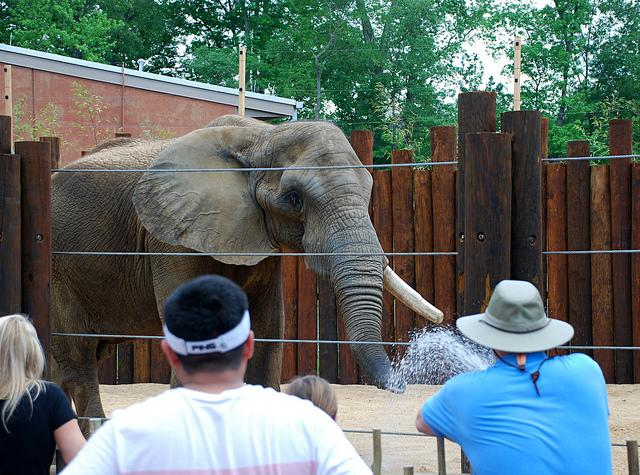What are people watching the elephant likely to use to shoot it? Please explain your reasoning. camera. The people have a camera. 